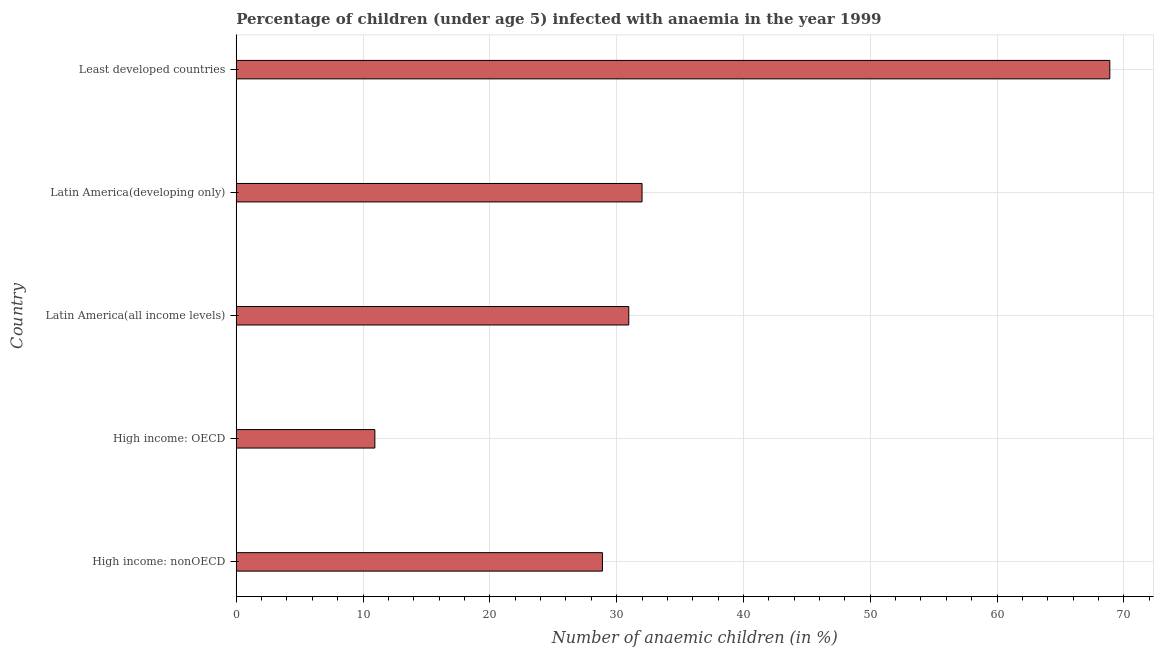Does the graph contain any zero values?
Your answer should be compact. No. What is the title of the graph?
Give a very brief answer. Percentage of children (under age 5) infected with anaemia in the year 1999. What is the label or title of the X-axis?
Keep it short and to the point. Number of anaemic children (in %). What is the label or title of the Y-axis?
Give a very brief answer. Country. What is the number of anaemic children in Latin America(developing only)?
Give a very brief answer. 32. Across all countries, what is the maximum number of anaemic children?
Keep it short and to the point. 68.89. Across all countries, what is the minimum number of anaemic children?
Your answer should be compact. 10.93. In which country was the number of anaemic children maximum?
Offer a terse response. Least developed countries. In which country was the number of anaemic children minimum?
Your answer should be compact. High income: OECD. What is the sum of the number of anaemic children?
Provide a succinct answer. 171.66. What is the difference between the number of anaemic children in High income: nonOECD and Latin America(all income levels)?
Keep it short and to the point. -2.08. What is the average number of anaemic children per country?
Provide a short and direct response. 34.33. What is the median number of anaemic children?
Your answer should be very brief. 30.95. In how many countries, is the number of anaemic children greater than 54 %?
Provide a short and direct response. 1. What is the ratio of the number of anaemic children in High income: OECD to that in Least developed countries?
Offer a terse response. 0.16. What is the difference between the highest and the second highest number of anaemic children?
Keep it short and to the point. 36.89. What is the difference between the highest and the lowest number of anaemic children?
Give a very brief answer. 57.96. In how many countries, is the number of anaemic children greater than the average number of anaemic children taken over all countries?
Your response must be concise. 1. How many countries are there in the graph?
Provide a short and direct response. 5. What is the difference between two consecutive major ticks on the X-axis?
Your response must be concise. 10. What is the Number of anaemic children (in %) of High income: nonOECD?
Your response must be concise. 28.88. What is the Number of anaemic children (in %) of High income: OECD?
Ensure brevity in your answer.  10.93. What is the Number of anaemic children (in %) of Latin America(all income levels)?
Your response must be concise. 30.95. What is the Number of anaemic children (in %) of Latin America(developing only)?
Your answer should be very brief. 32. What is the Number of anaemic children (in %) of Least developed countries?
Give a very brief answer. 68.89. What is the difference between the Number of anaemic children (in %) in High income: nonOECD and High income: OECD?
Offer a terse response. 17.95. What is the difference between the Number of anaemic children (in %) in High income: nonOECD and Latin America(all income levels)?
Your answer should be very brief. -2.08. What is the difference between the Number of anaemic children (in %) in High income: nonOECD and Latin America(developing only)?
Offer a very short reply. -3.12. What is the difference between the Number of anaemic children (in %) in High income: nonOECD and Least developed countries?
Your answer should be very brief. -40.01. What is the difference between the Number of anaemic children (in %) in High income: OECD and Latin America(all income levels)?
Give a very brief answer. -20.02. What is the difference between the Number of anaemic children (in %) in High income: OECD and Latin America(developing only)?
Provide a succinct answer. -21.07. What is the difference between the Number of anaemic children (in %) in High income: OECD and Least developed countries?
Your response must be concise. -57.96. What is the difference between the Number of anaemic children (in %) in Latin America(all income levels) and Latin America(developing only)?
Your answer should be very brief. -1.05. What is the difference between the Number of anaemic children (in %) in Latin America(all income levels) and Least developed countries?
Provide a short and direct response. -37.94. What is the difference between the Number of anaemic children (in %) in Latin America(developing only) and Least developed countries?
Provide a short and direct response. -36.89. What is the ratio of the Number of anaemic children (in %) in High income: nonOECD to that in High income: OECD?
Provide a succinct answer. 2.64. What is the ratio of the Number of anaemic children (in %) in High income: nonOECD to that in Latin America(all income levels)?
Provide a succinct answer. 0.93. What is the ratio of the Number of anaemic children (in %) in High income: nonOECD to that in Latin America(developing only)?
Provide a short and direct response. 0.9. What is the ratio of the Number of anaemic children (in %) in High income: nonOECD to that in Least developed countries?
Give a very brief answer. 0.42. What is the ratio of the Number of anaemic children (in %) in High income: OECD to that in Latin America(all income levels)?
Provide a short and direct response. 0.35. What is the ratio of the Number of anaemic children (in %) in High income: OECD to that in Latin America(developing only)?
Your answer should be very brief. 0.34. What is the ratio of the Number of anaemic children (in %) in High income: OECD to that in Least developed countries?
Your response must be concise. 0.16. What is the ratio of the Number of anaemic children (in %) in Latin America(all income levels) to that in Latin America(developing only)?
Offer a very short reply. 0.97. What is the ratio of the Number of anaemic children (in %) in Latin America(all income levels) to that in Least developed countries?
Ensure brevity in your answer.  0.45. What is the ratio of the Number of anaemic children (in %) in Latin America(developing only) to that in Least developed countries?
Provide a short and direct response. 0.47. 